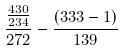<formula> <loc_0><loc_0><loc_500><loc_500>\frac { \frac { 4 3 0 } { 2 3 4 } } { 2 7 2 } - \frac { ( 3 3 3 - 1 ) } { 1 3 9 }</formula> 